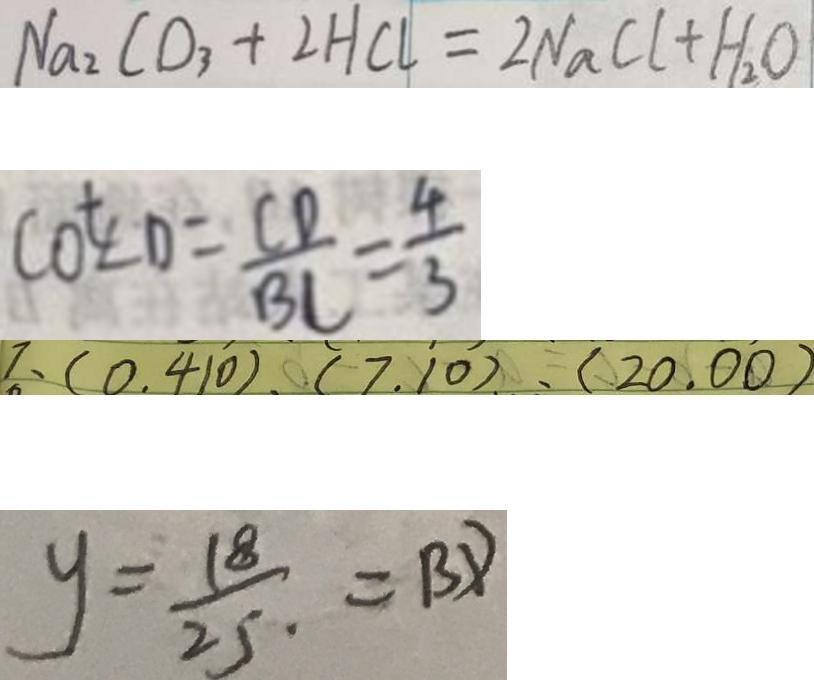Convert formula to latex. <formula><loc_0><loc_0><loc_500><loc_500>N a _ { 2 } C O _ { 3 } + 2 H C l = 2 N a C l + H _ { 2 } O 
 \cot \angle D = \frac { C D } { B C } = \frac { 4 } { 3 } 
 7 、 ( 0 . 4 1 0 ) . ( 7 . 1 0 ) . ( 2 0 . 0 0 ) 
 y = \frac { 1 8 } { 2 5 } = B D</formula> 